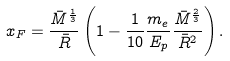Convert formula to latex. <formula><loc_0><loc_0><loc_500><loc_500>x _ { F } = \frac { \bar { M } ^ { \frac { 1 } { 3 } } } { \bar { R } } \left ( 1 - \frac { 1 } { 1 0 } \frac { m _ { e } } { E _ { p } } \frac { \bar { M } ^ { \frac { 2 } { 3 } } } { \bar { R } ^ { 2 } } \right ) .</formula> 